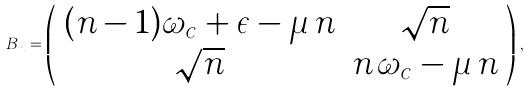<formula> <loc_0><loc_0><loc_500><loc_500>B _ { n } = \left ( \begin{array} { c c } ( n - 1 ) \omega _ { c } + \epsilon - \mu \, n & \sqrt { n } \\ \sqrt { n } & n \, \omega _ { c } - \mu \, n \end{array} \right ) \, ,</formula> 